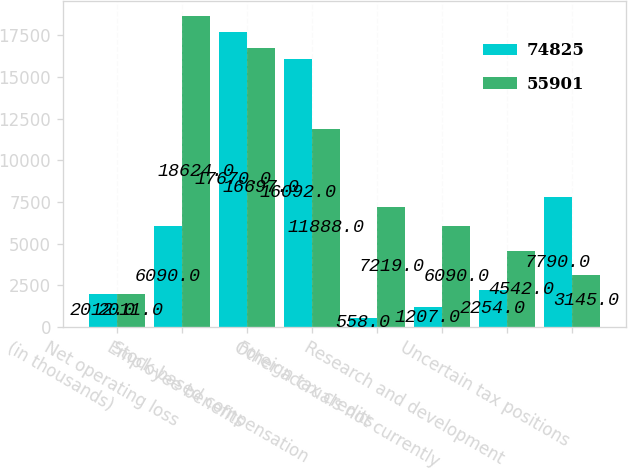<chart> <loc_0><loc_0><loc_500><loc_500><stacked_bar_chart><ecel><fcel>(in thousands)<fcel>Net operating loss<fcel>Employee benefits<fcel>Stock-based compensation<fcel>Foreign tax credits<fcel>Other accruals not currently<fcel>Research and development<fcel>Uncertain tax positions<nl><fcel>74825<fcel>2012<fcel>6090<fcel>17670<fcel>16092<fcel>558<fcel>1207<fcel>2254<fcel>7790<nl><fcel>55901<fcel>2011<fcel>18624<fcel>16697<fcel>11888<fcel>7219<fcel>6090<fcel>4542<fcel>3145<nl></chart> 